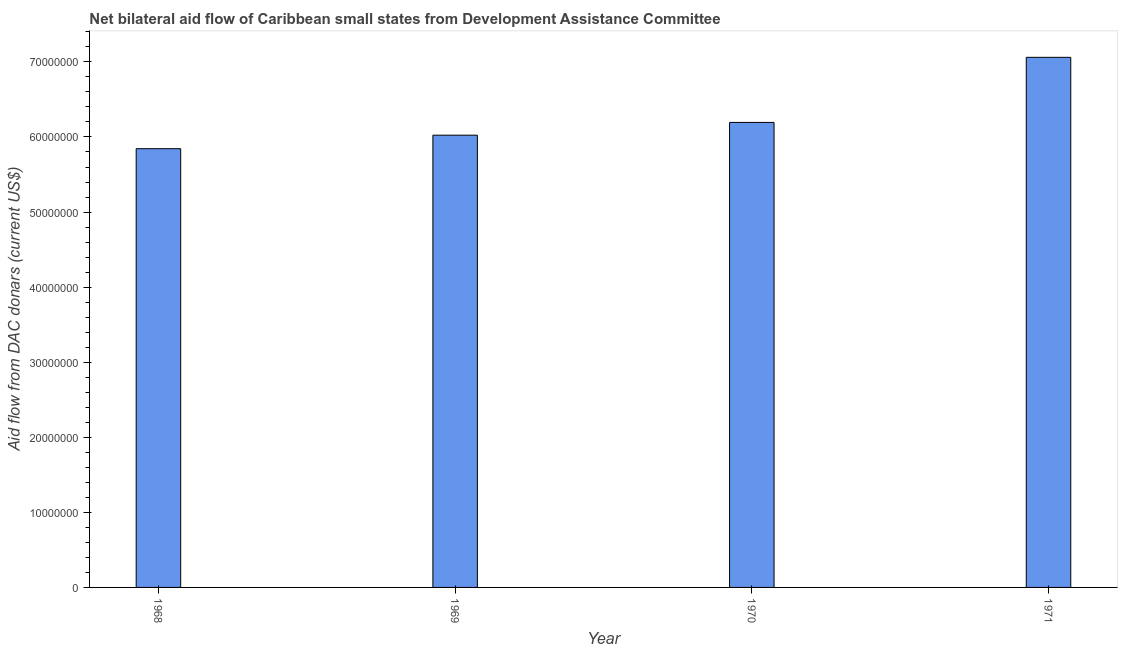Does the graph contain any zero values?
Your answer should be very brief. No. Does the graph contain grids?
Your response must be concise. No. What is the title of the graph?
Keep it short and to the point. Net bilateral aid flow of Caribbean small states from Development Assistance Committee. What is the label or title of the Y-axis?
Your answer should be very brief. Aid flow from DAC donars (current US$). What is the net bilateral aid flows from dac donors in 1969?
Ensure brevity in your answer.  6.02e+07. Across all years, what is the maximum net bilateral aid flows from dac donors?
Provide a succinct answer. 7.06e+07. Across all years, what is the minimum net bilateral aid flows from dac donors?
Ensure brevity in your answer.  5.84e+07. In which year was the net bilateral aid flows from dac donors maximum?
Make the answer very short. 1971. In which year was the net bilateral aid flows from dac donors minimum?
Keep it short and to the point. 1968. What is the sum of the net bilateral aid flows from dac donors?
Offer a terse response. 2.51e+08. What is the difference between the net bilateral aid flows from dac donors in 1969 and 1971?
Offer a terse response. -1.04e+07. What is the average net bilateral aid flows from dac donors per year?
Make the answer very short. 6.28e+07. What is the median net bilateral aid flows from dac donors?
Give a very brief answer. 6.11e+07. Do a majority of the years between 1969 and 1971 (inclusive) have net bilateral aid flows from dac donors greater than 44000000 US$?
Your answer should be compact. Yes. What is the ratio of the net bilateral aid flows from dac donors in 1968 to that in 1971?
Make the answer very short. 0.83. Is the net bilateral aid flows from dac donors in 1968 less than that in 1971?
Keep it short and to the point. Yes. Is the difference between the net bilateral aid flows from dac donors in 1968 and 1971 greater than the difference between any two years?
Provide a succinct answer. Yes. What is the difference between the highest and the second highest net bilateral aid flows from dac donors?
Provide a succinct answer. 8.67e+06. Is the sum of the net bilateral aid flows from dac donors in 1969 and 1970 greater than the maximum net bilateral aid flows from dac donors across all years?
Provide a succinct answer. Yes. What is the difference between the highest and the lowest net bilateral aid flows from dac donors?
Provide a succinct answer. 1.22e+07. How many bars are there?
Make the answer very short. 4. What is the Aid flow from DAC donars (current US$) in 1968?
Provide a short and direct response. 5.84e+07. What is the Aid flow from DAC donars (current US$) in 1969?
Offer a terse response. 6.02e+07. What is the Aid flow from DAC donars (current US$) of 1970?
Your answer should be very brief. 6.19e+07. What is the Aid flow from DAC donars (current US$) in 1971?
Ensure brevity in your answer.  7.06e+07. What is the difference between the Aid flow from DAC donars (current US$) in 1968 and 1969?
Keep it short and to the point. -1.80e+06. What is the difference between the Aid flow from DAC donars (current US$) in 1968 and 1970?
Offer a terse response. -3.50e+06. What is the difference between the Aid flow from DAC donars (current US$) in 1968 and 1971?
Ensure brevity in your answer.  -1.22e+07. What is the difference between the Aid flow from DAC donars (current US$) in 1969 and 1970?
Make the answer very short. -1.70e+06. What is the difference between the Aid flow from DAC donars (current US$) in 1969 and 1971?
Your answer should be compact. -1.04e+07. What is the difference between the Aid flow from DAC donars (current US$) in 1970 and 1971?
Make the answer very short. -8.67e+06. What is the ratio of the Aid flow from DAC donars (current US$) in 1968 to that in 1969?
Provide a short and direct response. 0.97. What is the ratio of the Aid flow from DAC donars (current US$) in 1968 to that in 1970?
Make the answer very short. 0.94. What is the ratio of the Aid flow from DAC donars (current US$) in 1968 to that in 1971?
Your response must be concise. 0.83. What is the ratio of the Aid flow from DAC donars (current US$) in 1969 to that in 1971?
Your response must be concise. 0.85. What is the ratio of the Aid flow from DAC donars (current US$) in 1970 to that in 1971?
Give a very brief answer. 0.88. 